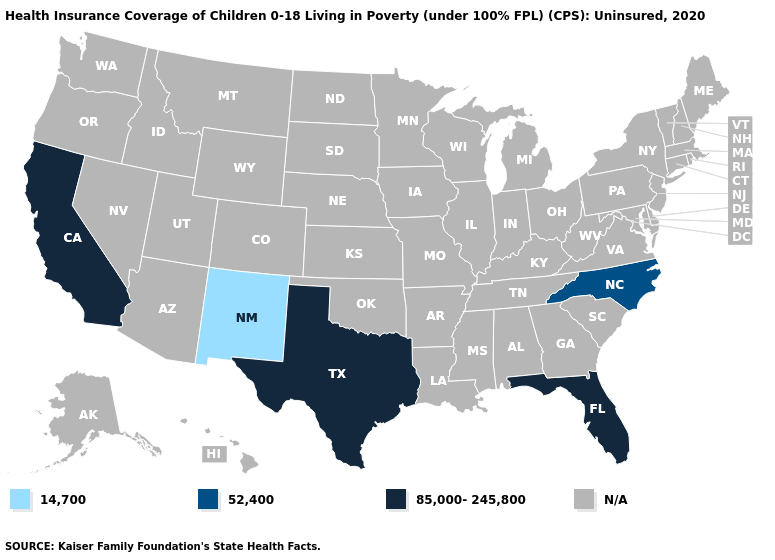Name the states that have a value in the range N/A?
Be succinct. Alabama, Alaska, Arizona, Arkansas, Colorado, Connecticut, Delaware, Georgia, Hawaii, Idaho, Illinois, Indiana, Iowa, Kansas, Kentucky, Louisiana, Maine, Maryland, Massachusetts, Michigan, Minnesota, Mississippi, Missouri, Montana, Nebraska, Nevada, New Hampshire, New Jersey, New York, North Dakota, Ohio, Oklahoma, Oregon, Pennsylvania, Rhode Island, South Carolina, South Dakota, Tennessee, Utah, Vermont, Virginia, Washington, West Virginia, Wisconsin, Wyoming. What is the value of New Hampshire?
Write a very short answer. N/A. What is the lowest value in states that border South Carolina?
Quick response, please. 52,400. What is the value of Nevada?
Keep it brief. N/A. Name the states that have a value in the range 52,400?
Answer briefly. North Carolina. What is the value of Kansas?
Short answer required. N/A. Which states have the lowest value in the South?
Keep it brief. North Carolina. Does the map have missing data?
Be succinct. Yes. What is the value of Missouri?
Short answer required. N/A. Which states have the lowest value in the USA?
Be succinct. New Mexico. Does Florida have the highest value in the South?
Short answer required. Yes. Name the states that have a value in the range N/A?
Answer briefly. Alabama, Alaska, Arizona, Arkansas, Colorado, Connecticut, Delaware, Georgia, Hawaii, Idaho, Illinois, Indiana, Iowa, Kansas, Kentucky, Louisiana, Maine, Maryland, Massachusetts, Michigan, Minnesota, Mississippi, Missouri, Montana, Nebraska, Nevada, New Hampshire, New Jersey, New York, North Dakota, Ohio, Oklahoma, Oregon, Pennsylvania, Rhode Island, South Carolina, South Dakota, Tennessee, Utah, Vermont, Virginia, Washington, West Virginia, Wisconsin, Wyoming. 